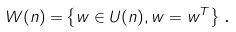<formula> <loc_0><loc_0><loc_500><loc_500>W ( n \mathbb { ) = } \left \{ w \in U ( n \mathbb { ) } , w = w ^ { T } \right \} \text {.}</formula> 